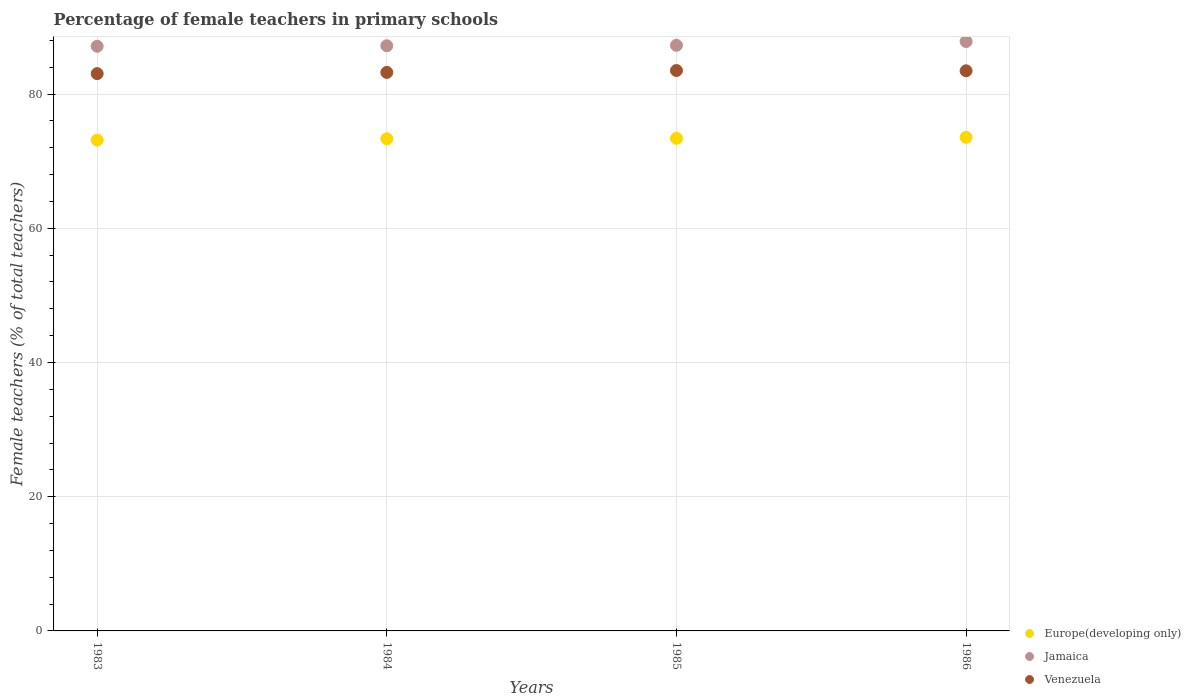Is the number of dotlines equal to the number of legend labels?
Offer a very short reply. Yes. What is the percentage of female teachers in Europe(developing only) in 1984?
Give a very brief answer. 73.34. Across all years, what is the maximum percentage of female teachers in Jamaica?
Make the answer very short. 87.83. Across all years, what is the minimum percentage of female teachers in Venezuela?
Your response must be concise. 83.05. What is the total percentage of female teachers in Europe(developing only) in the graph?
Ensure brevity in your answer.  293.44. What is the difference between the percentage of female teachers in Venezuela in 1985 and that in 1986?
Provide a short and direct response. 0.04. What is the difference between the percentage of female teachers in Europe(developing only) in 1983 and the percentage of female teachers in Jamaica in 1986?
Offer a terse response. -14.69. What is the average percentage of female teachers in Venezuela per year?
Your answer should be compact. 83.31. In the year 1983, what is the difference between the percentage of female teachers in Venezuela and percentage of female teachers in Europe(developing only)?
Make the answer very short. 9.9. In how many years, is the percentage of female teachers in Jamaica greater than 16 %?
Offer a very short reply. 4. What is the ratio of the percentage of female teachers in Europe(developing only) in 1983 to that in 1986?
Your answer should be compact. 0.99. Is the difference between the percentage of female teachers in Venezuela in 1984 and 1986 greater than the difference between the percentage of female teachers in Europe(developing only) in 1984 and 1986?
Your answer should be compact. No. What is the difference between the highest and the second highest percentage of female teachers in Jamaica?
Your answer should be very brief. 0.57. What is the difference between the highest and the lowest percentage of female teachers in Europe(developing only)?
Offer a very short reply. 0.41. Is it the case that in every year, the sum of the percentage of female teachers in Jamaica and percentage of female teachers in Europe(developing only)  is greater than the percentage of female teachers in Venezuela?
Make the answer very short. Yes. Is the percentage of female teachers in Europe(developing only) strictly greater than the percentage of female teachers in Jamaica over the years?
Provide a short and direct response. No. Is the percentage of female teachers in Venezuela strictly less than the percentage of female teachers in Europe(developing only) over the years?
Your answer should be very brief. No. How many dotlines are there?
Ensure brevity in your answer.  3. Does the graph contain any zero values?
Make the answer very short. No. How are the legend labels stacked?
Your answer should be very brief. Vertical. What is the title of the graph?
Your answer should be very brief. Percentage of female teachers in primary schools. What is the label or title of the Y-axis?
Ensure brevity in your answer.  Female teachers (% of total teachers). What is the Female teachers (% of total teachers) of Europe(developing only) in 1983?
Your response must be concise. 73.15. What is the Female teachers (% of total teachers) in Jamaica in 1983?
Give a very brief answer. 87.12. What is the Female teachers (% of total teachers) of Venezuela in 1983?
Provide a succinct answer. 83.05. What is the Female teachers (% of total teachers) in Europe(developing only) in 1984?
Give a very brief answer. 73.34. What is the Female teachers (% of total teachers) in Jamaica in 1984?
Make the answer very short. 87.2. What is the Female teachers (% of total teachers) in Venezuela in 1984?
Keep it short and to the point. 83.23. What is the Female teachers (% of total teachers) of Europe(developing only) in 1985?
Give a very brief answer. 73.41. What is the Female teachers (% of total teachers) in Jamaica in 1985?
Offer a terse response. 87.26. What is the Female teachers (% of total teachers) of Venezuela in 1985?
Your answer should be compact. 83.51. What is the Female teachers (% of total teachers) of Europe(developing only) in 1986?
Offer a very short reply. 73.55. What is the Female teachers (% of total teachers) of Jamaica in 1986?
Ensure brevity in your answer.  87.83. What is the Female teachers (% of total teachers) of Venezuela in 1986?
Keep it short and to the point. 83.47. Across all years, what is the maximum Female teachers (% of total teachers) in Europe(developing only)?
Provide a succinct answer. 73.55. Across all years, what is the maximum Female teachers (% of total teachers) of Jamaica?
Your answer should be very brief. 87.83. Across all years, what is the maximum Female teachers (% of total teachers) of Venezuela?
Offer a very short reply. 83.51. Across all years, what is the minimum Female teachers (% of total teachers) of Europe(developing only)?
Offer a very short reply. 73.15. Across all years, what is the minimum Female teachers (% of total teachers) in Jamaica?
Give a very brief answer. 87.12. Across all years, what is the minimum Female teachers (% of total teachers) of Venezuela?
Provide a short and direct response. 83.05. What is the total Female teachers (% of total teachers) of Europe(developing only) in the graph?
Give a very brief answer. 293.44. What is the total Female teachers (% of total teachers) in Jamaica in the graph?
Your answer should be compact. 349.42. What is the total Female teachers (% of total teachers) of Venezuela in the graph?
Provide a succinct answer. 333.25. What is the difference between the Female teachers (% of total teachers) in Europe(developing only) in 1983 and that in 1984?
Provide a short and direct response. -0.19. What is the difference between the Female teachers (% of total teachers) of Jamaica in 1983 and that in 1984?
Offer a very short reply. -0.08. What is the difference between the Female teachers (% of total teachers) of Venezuela in 1983 and that in 1984?
Keep it short and to the point. -0.18. What is the difference between the Female teachers (% of total teachers) in Europe(developing only) in 1983 and that in 1985?
Offer a terse response. -0.26. What is the difference between the Female teachers (% of total teachers) in Jamaica in 1983 and that in 1985?
Keep it short and to the point. -0.14. What is the difference between the Female teachers (% of total teachers) in Venezuela in 1983 and that in 1985?
Offer a terse response. -0.46. What is the difference between the Female teachers (% of total teachers) of Europe(developing only) in 1983 and that in 1986?
Your response must be concise. -0.41. What is the difference between the Female teachers (% of total teachers) in Jamaica in 1983 and that in 1986?
Keep it short and to the point. -0.71. What is the difference between the Female teachers (% of total teachers) in Venezuela in 1983 and that in 1986?
Ensure brevity in your answer.  -0.42. What is the difference between the Female teachers (% of total teachers) in Europe(developing only) in 1984 and that in 1985?
Give a very brief answer. -0.07. What is the difference between the Female teachers (% of total teachers) of Jamaica in 1984 and that in 1985?
Your response must be concise. -0.07. What is the difference between the Female teachers (% of total teachers) in Venezuela in 1984 and that in 1985?
Keep it short and to the point. -0.28. What is the difference between the Female teachers (% of total teachers) in Europe(developing only) in 1984 and that in 1986?
Your response must be concise. -0.22. What is the difference between the Female teachers (% of total teachers) of Jamaica in 1984 and that in 1986?
Your response must be concise. -0.63. What is the difference between the Female teachers (% of total teachers) of Venezuela in 1984 and that in 1986?
Your answer should be very brief. -0.24. What is the difference between the Female teachers (% of total teachers) in Europe(developing only) in 1985 and that in 1986?
Provide a succinct answer. -0.14. What is the difference between the Female teachers (% of total teachers) of Jamaica in 1985 and that in 1986?
Give a very brief answer. -0.57. What is the difference between the Female teachers (% of total teachers) of Venezuela in 1985 and that in 1986?
Keep it short and to the point. 0.04. What is the difference between the Female teachers (% of total teachers) in Europe(developing only) in 1983 and the Female teachers (% of total teachers) in Jamaica in 1984?
Offer a very short reply. -14.05. What is the difference between the Female teachers (% of total teachers) of Europe(developing only) in 1983 and the Female teachers (% of total teachers) of Venezuela in 1984?
Offer a very short reply. -10.08. What is the difference between the Female teachers (% of total teachers) of Jamaica in 1983 and the Female teachers (% of total teachers) of Venezuela in 1984?
Your answer should be compact. 3.89. What is the difference between the Female teachers (% of total teachers) of Europe(developing only) in 1983 and the Female teachers (% of total teachers) of Jamaica in 1985?
Your answer should be compact. -14.12. What is the difference between the Female teachers (% of total teachers) of Europe(developing only) in 1983 and the Female teachers (% of total teachers) of Venezuela in 1985?
Keep it short and to the point. -10.36. What is the difference between the Female teachers (% of total teachers) in Jamaica in 1983 and the Female teachers (% of total teachers) in Venezuela in 1985?
Your answer should be very brief. 3.61. What is the difference between the Female teachers (% of total teachers) in Europe(developing only) in 1983 and the Female teachers (% of total teachers) in Jamaica in 1986?
Your answer should be compact. -14.69. What is the difference between the Female teachers (% of total teachers) of Europe(developing only) in 1983 and the Female teachers (% of total teachers) of Venezuela in 1986?
Give a very brief answer. -10.32. What is the difference between the Female teachers (% of total teachers) in Jamaica in 1983 and the Female teachers (% of total teachers) in Venezuela in 1986?
Offer a terse response. 3.65. What is the difference between the Female teachers (% of total teachers) of Europe(developing only) in 1984 and the Female teachers (% of total teachers) of Jamaica in 1985?
Keep it short and to the point. -13.93. What is the difference between the Female teachers (% of total teachers) of Europe(developing only) in 1984 and the Female teachers (% of total teachers) of Venezuela in 1985?
Provide a succinct answer. -10.17. What is the difference between the Female teachers (% of total teachers) in Jamaica in 1984 and the Female teachers (% of total teachers) in Venezuela in 1985?
Ensure brevity in your answer.  3.69. What is the difference between the Female teachers (% of total teachers) in Europe(developing only) in 1984 and the Female teachers (% of total teachers) in Jamaica in 1986?
Give a very brief answer. -14.5. What is the difference between the Female teachers (% of total teachers) in Europe(developing only) in 1984 and the Female teachers (% of total teachers) in Venezuela in 1986?
Offer a very short reply. -10.13. What is the difference between the Female teachers (% of total teachers) in Jamaica in 1984 and the Female teachers (% of total teachers) in Venezuela in 1986?
Provide a short and direct response. 3.73. What is the difference between the Female teachers (% of total teachers) in Europe(developing only) in 1985 and the Female teachers (% of total teachers) in Jamaica in 1986?
Offer a very short reply. -14.42. What is the difference between the Female teachers (% of total teachers) of Europe(developing only) in 1985 and the Female teachers (% of total teachers) of Venezuela in 1986?
Give a very brief answer. -10.06. What is the difference between the Female teachers (% of total teachers) in Jamaica in 1985 and the Female teachers (% of total teachers) in Venezuela in 1986?
Ensure brevity in your answer.  3.8. What is the average Female teachers (% of total teachers) in Europe(developing only) per year?
Give a very brief answer. 73.36. What is the average Female teachers (% of total teachers) in Jamaica per year?
Your response must be concise. 87.35. What is the average Female teachers (% of total teachers) in Venezuela per year?
Ensure brevity in your answer.  83.31. In the year 1983, what is the difference between the Female teachers (% of total teachers) in Europe(developing only) and Female teachers (% of total teachers) in Jamaica?
Offer a very short reply. -13.98. In the year 1983, what is the difference between the Female teachers (% of total teachers) in Europe(developing only) and Female teachers (% of total teachers) in Venezuela?
Keep it short and to the point. -9.9. In the year 1983, what is the difference between the Female teachers (% of total teachers) in Jamaica and Female teachers (% of total teachers) in Venezuela?
Offer a terse response. 4.07. In the year 1984, what is the difference between the Female teachers (% of total teachers) in Europe(developing only) and Female teachers (% of total teachers) in Jamaica?
Your answer should be very brief. -13.86. In the year 1984, what is the difference between the Female teachers (% of total teachers) of Europe(developing only) and Female teachers (% of total teachers) of Venezuela?
Give a very brief answer. -9.89. In the year 1984, what is the difference between the Female teachers (% of total teachers) of Jamaica and Female teachers (% of total teachers) of Venezuela?
Provide a short and direct response. 3.97. In the year 1985, what is the difference between the Female teachers (% of total teachers) in Europe(developing only) and Female teachers (% of total teachers) in Jamaica?
Provide a short and direct response. -13.86. In the year 1985, what is the difference between the Female teachers (% of total teachers) of Europe(developing only) and Female teachers (% of total teachers) of Venezuela?
Your answer should be very brief. -10.1. In the year 1985, what is the difference between the Female teachers (% of total teachers) of Jamaica and Female teachers (% of total teachers) of Venezuela?
Your answer should be compact. 3.76. In the year 1986, what is the difference between the Female teachers (% of total teachers) of Europe(developing only) and Female teachers (% of total teachers) of Jamaica?
Give a very brief answer. -14.28. In the year 1986, what is the difference between the Female teachers (% of total teachers) of Europe(developing only) and Female teachers (% of total teachers) of Venezuela?
Offer a terse response. -9.92. In the year 1986, what is the difference between the Female teachers (% of total teachers) in Jamaica and Female teachers (% of total teachers) in Venezuela?
Your answer should be compact. 4.36. What is the ratio of the Female teachers (% of total teachers) of Europe(developing only) in 1983 to that in 1984?
Give a very brief answer. 1. What is the ratio of the Female teachers (% of total teachers) in Europe(developing only) in 1983 to that in 1985?
Provide a short and direct response. 1. What is the ratio of the Female teachers (% of total teachers) in Jamaica in 1983 to that in 1986?
Your answer should be compact. 0.99. What is the ratio of the Female teachers (% of total teachers) of Venezuela in 1983 to that in 1986?
Give a very brief answer. 0.99. What is the ratio of the Female teachers (% of total teachers) of Jamaica in 1984 to that in 1985?
Keep it short and to the point. 1. What is the ratio of the Female teachers (% of total teachers) in Venezuela in 1984 to that in 1985?
Keep it short and to the point. 1. What is the ratio of the Female teachers (% of total teachers) of Jamaica in 1984 to that in 1986?
Your response must be concise. 0.99. What is the ratio of the Female teachers (% of total teachers) in Venezuela in 1984 to that in 1986?
Offer a terse response. 1. What is the difference between the highest and the second highest Female teachers (% of total teachers) in Europe(developing only)?
Offer a terse response. 0.14. What is the difference between the highest and the second highest Female teachers (% of total teachers) in Jamaica?
Provide a short and direct response. 0.57. What is the difference between the highest and the second highest Female teachers (% of total teachers) in Venezuela?
Make the answer very short. 0.04. What is the difference between the highest and the lowest Female teachers (% of total teachers) in Europe(developing only)?
Offer a very short reply. 0.41. What is the difference between the highest and the lowest Female teachers (% of total teachers) in Jamaica?
Ensure brevity in your answer.  0.71. What is the difference between the highest and the lowest Female teachers (% of total teachers) of Venezuela?
Make the answer very short. 0.46. 